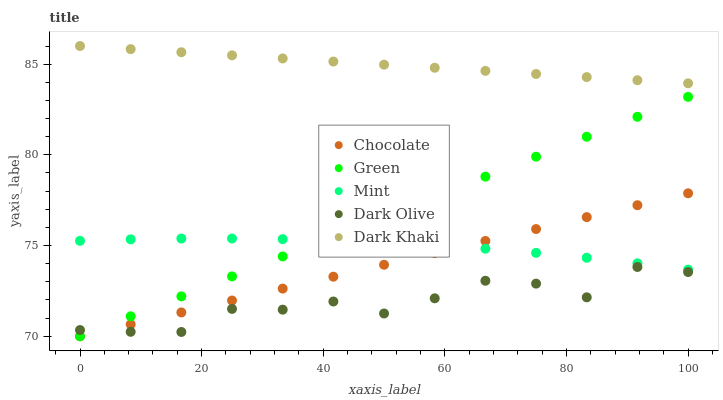Does Dark Olive have the minimum area under the curve?
Answer yes or no. Yes. Does Dark Khaki have the maximum area under the curve?
Answer yes or no. Yes. Does Mint have the minimum area under the curve?
Answer yes or no. No. Does Mint have the maximum area under the curve?
Answer yes or no. No. Is Dark Khaki the smoothest?
Answer yes or no. Yes. Is Dark Olive the roughest?
Answer yes or no. Yes. Is Mint the smoothest?
Answer yes or no. No. Is Mint the roughest?
Answer yes or no. No. Does Green have the lowest value?
Answer yes or no. Yes. Does Mint have the lowest value?
Answer yes or no. No. Does Dark Khaki have the highest value?
Answer yes or no. Yes. Does Mint have the highest value?
Answer yes or no. No. Is Green less than Dark Khaki?
Answer yes or no. Yes. Is Dark Khaki greater than Green?
Answer yes or no. Yes. Does Green intersect Dark Olive?
Answer yes or no. Yes. Is Green less than Dark Olive?
Answer yes or no. No. Is Green greater than Dark Olive?
Answer yes or no. No. Does Green intersect Dark Khaki?
Answer yes or no. No. 